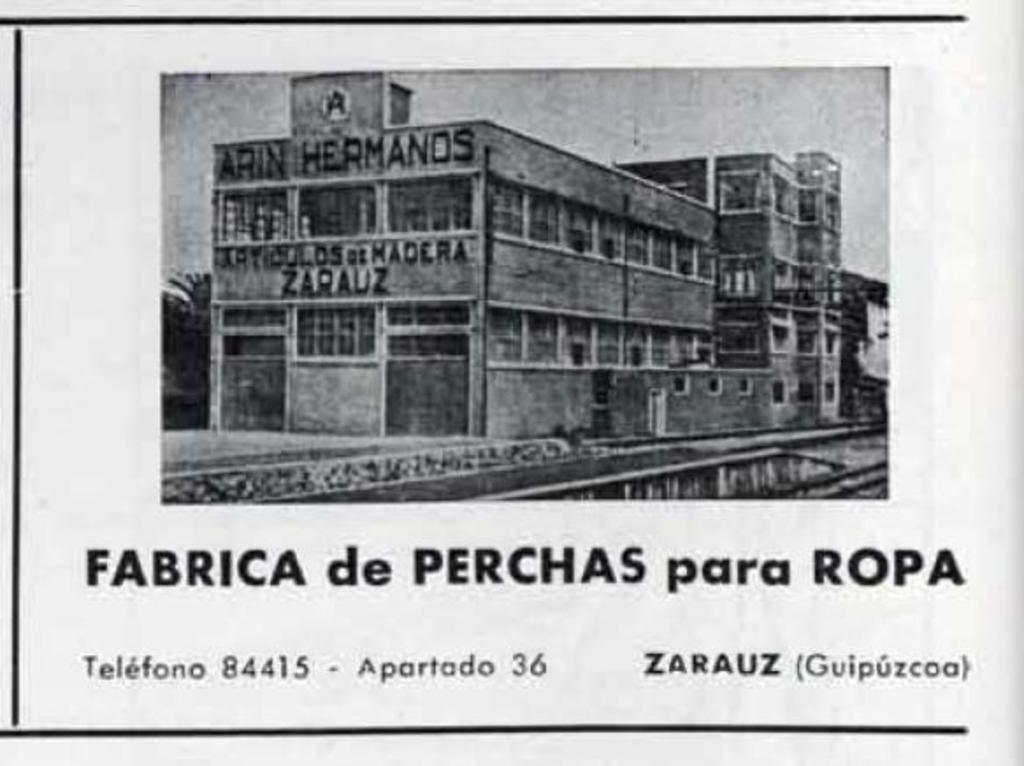What is the main subject of the picture? The main subject of the picture is a building. Does the building have any identifying features? Yes, the building has a name plate. What is the color scheme of the picture? The picture is black and white. What additional information is provided at the bottom of the picture? There is text written at the bottom of the picture. How many dogs are visible in the picture? There are no dogs present in the picture; it features a building with a name plate. What type of weather is depicted in the picture? The picture is black and white, so it does not depict any specific weather conditions. 